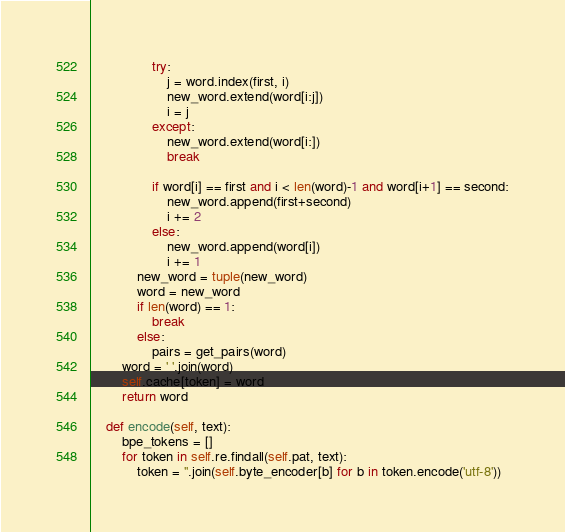Convert code to text. <code><loc_0><loc_0><loc_500><loc_500><_Python_>                try:
                    j = word.index(first, i)
                    new_word.extend(word[i:j])
                    i = j
                except:
                    new_word.extend(word[i:])
                    break

                if word[i] == first and i < len(word)-1 and word[i+1] == second:
                    new_word.append(first+second)
                    i += 2
                else:
                    new_word.append(word[i])
                    i += 1
            new_word = tuple(new_word)
            word = new_word
            if len(word) == 1:
                break
            else:
                pairs = get_pairs(word)
        word = ' '.join(word)
        self.cache[token] = word
        return word

    def encode(self, text):
        bpe_tokens = []
        for token in self.re.findall(self.pat, text):
            token = ''.join(self.byte_encoder[b] for b in token.encode('utf-8'))</code> 